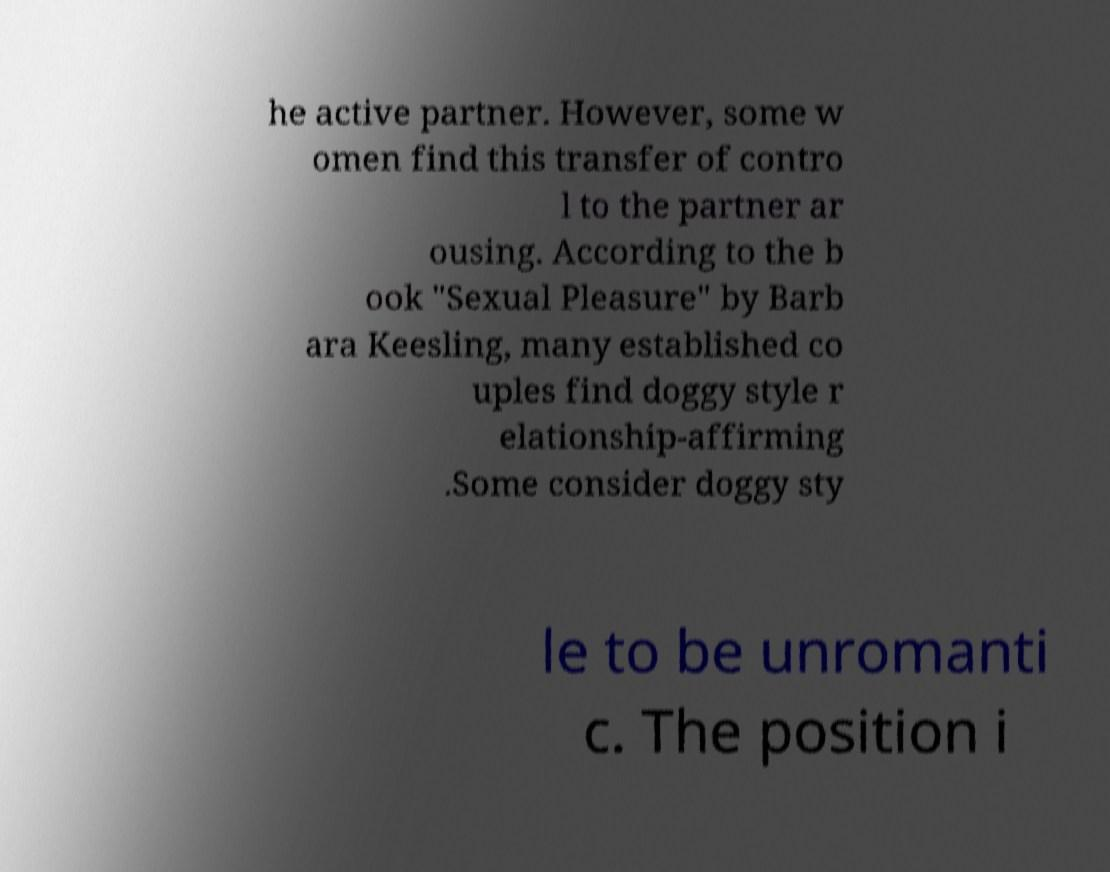I need the written content from this picture converted into text. Can you do that? he active partner. However, some w omen find this transfer of contro l to the partner ar ousing. According to the b ook "Sexual Pleasure" by Barb ara Keesling, many established co uples find doggy style r elationship-affirming .Some consider doggy sty le to be unromanti c. The position i 